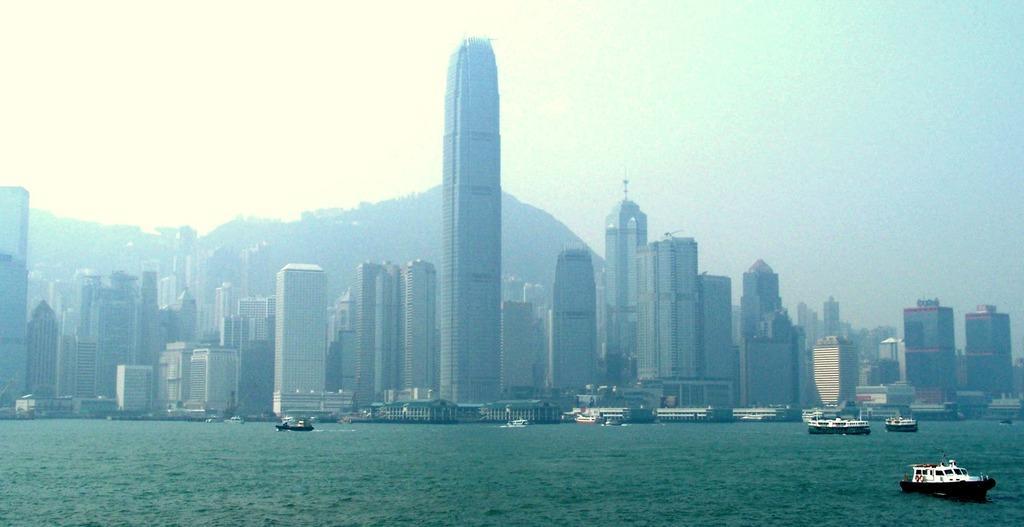Can you describe this image briefly? There are ships on the water at the bottom side of the image and there are skyscrapers in the center, it seems like a mountain and the sky in the background. 